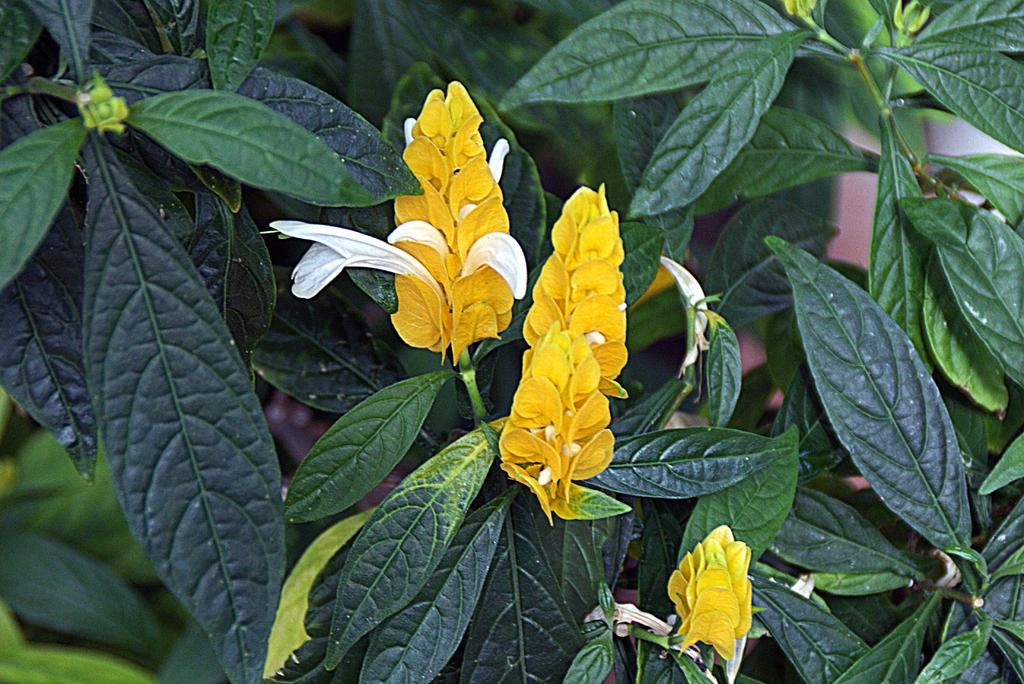What type of living organisms can be seen in the image? There are flowers in the image. Where are the flowers located? The flowers are present on plants. What type of shock can be seen affecting the plants in the image? There is no shock present in the image; it features flowers on plants. How many crackers are visible on the plants in the image? There are no crackers present in the image; it features flowers on plants. 